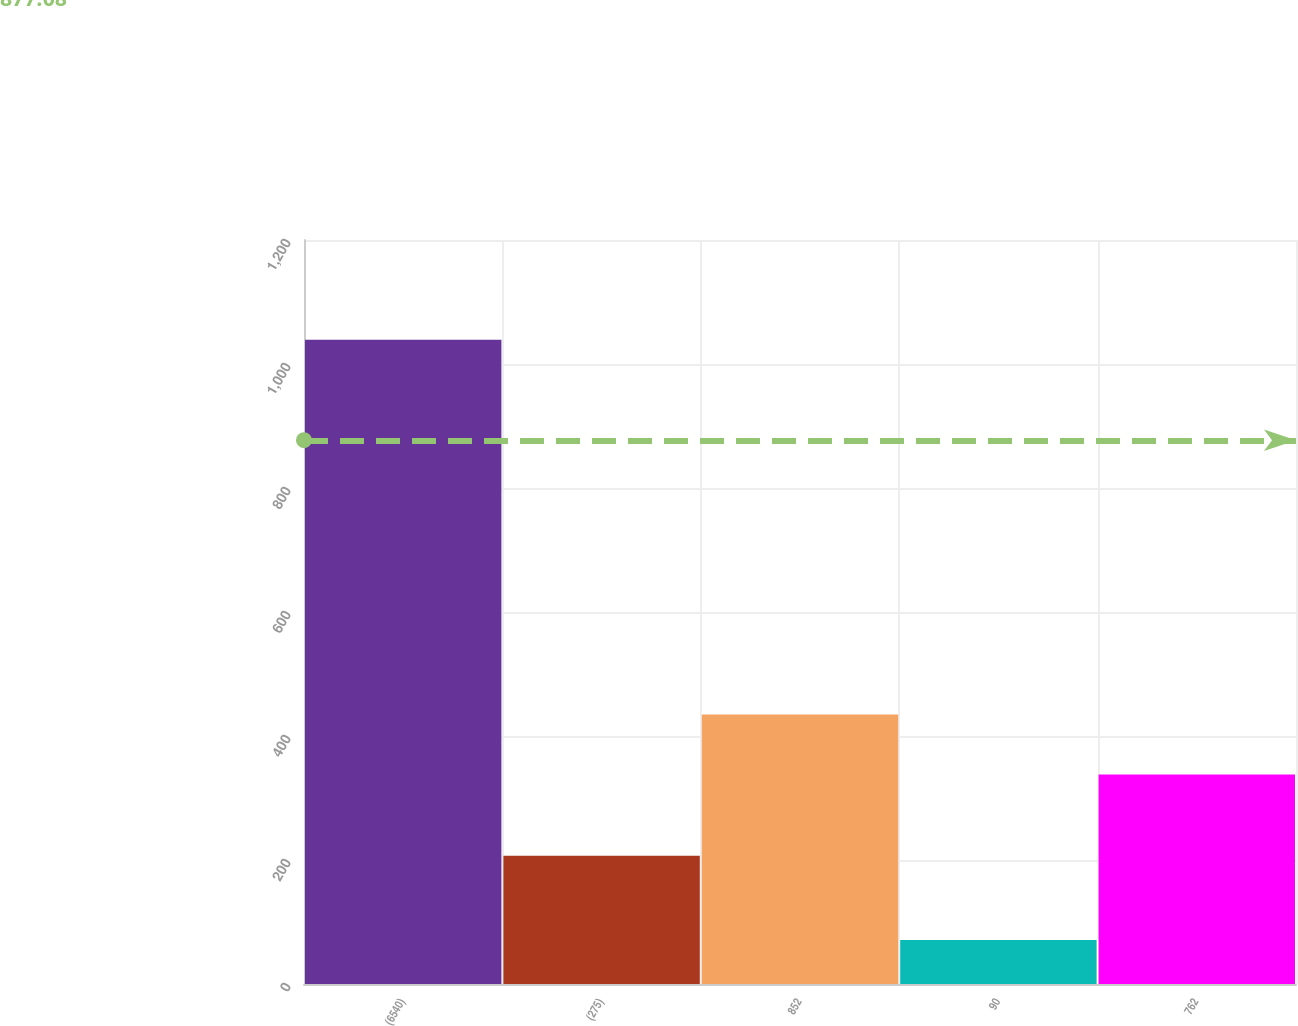Convert chart to OTSL. <chart><loc_0><loc_0><loc_500><loc_500><bar_chart><fcel>(6540)<fcel>(275)<fcel>852<fcel>90<fcel>762<nl><fcel>1039<fcel>207<fcel>434.8<fcel>71<fcel>338<nl></chart> 